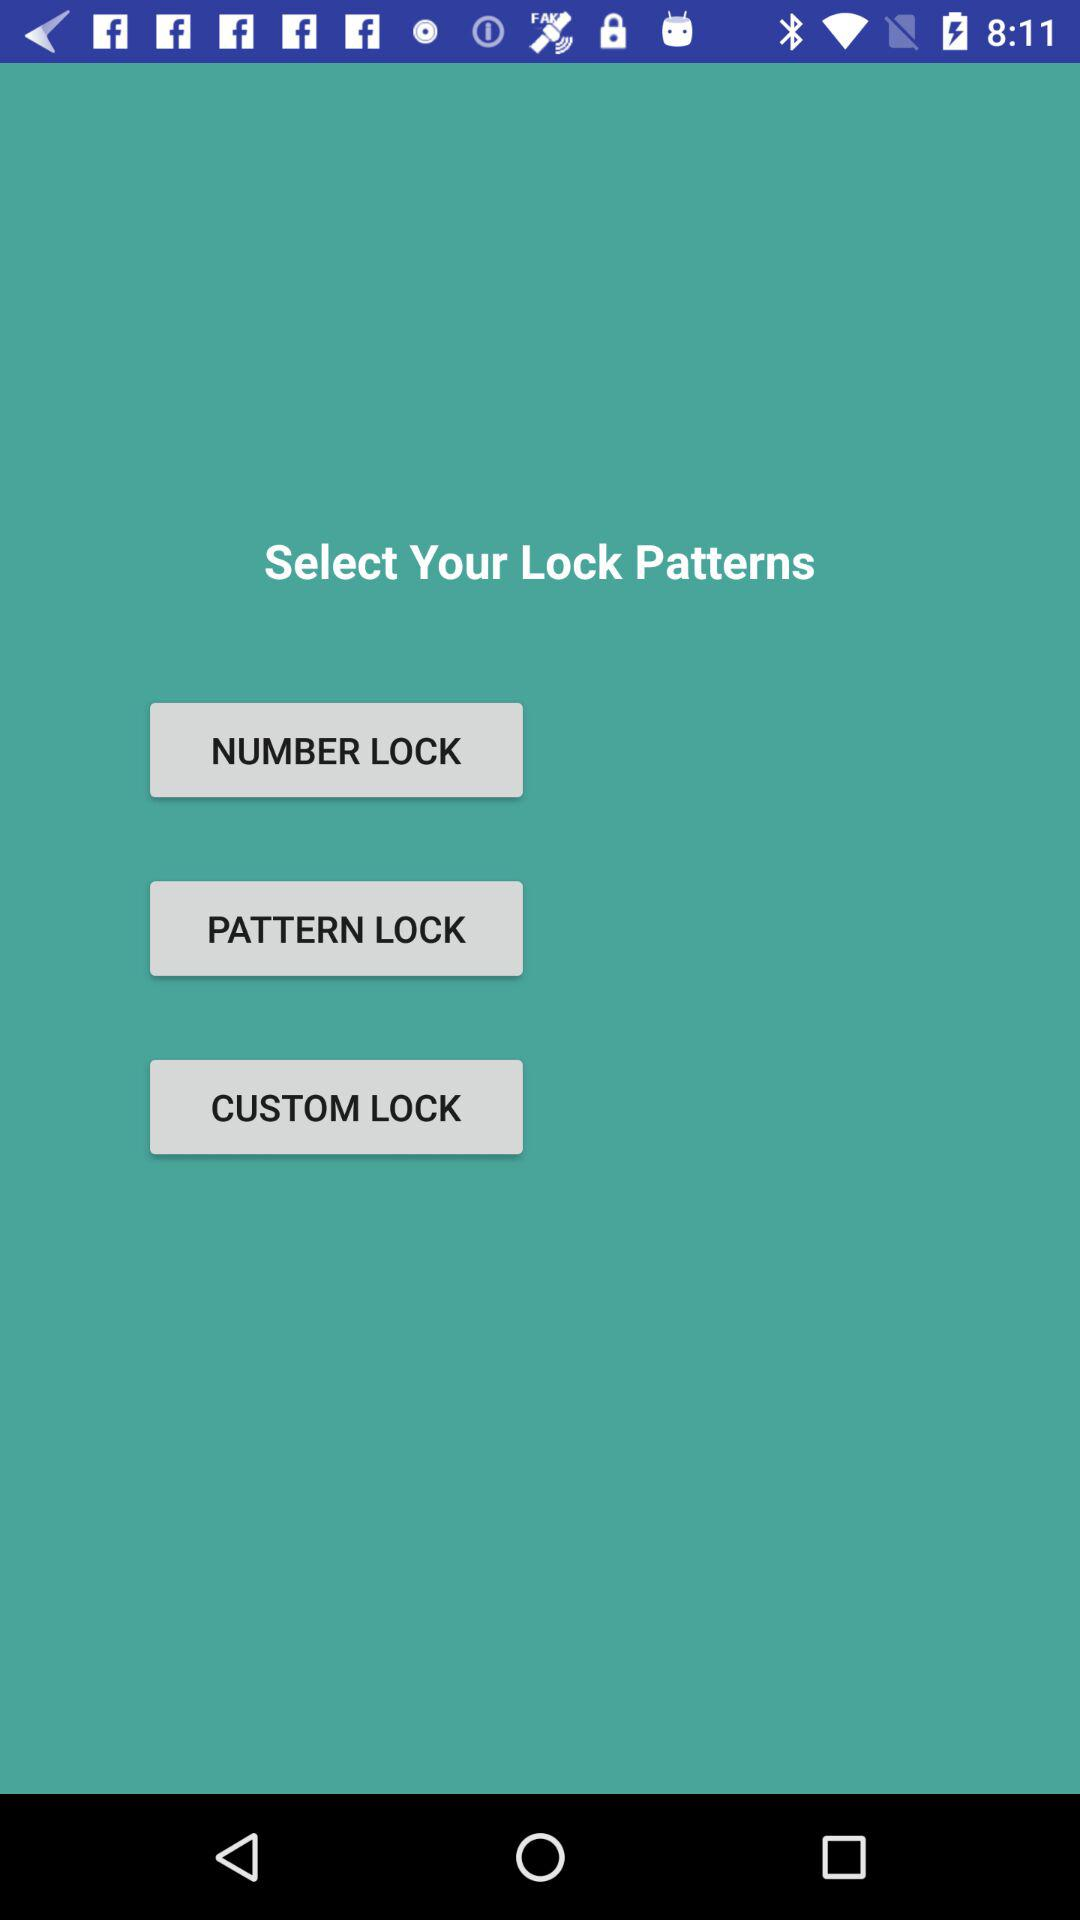How many options are there for locking my phone?
Answer the question using a single word or phrase. 3 